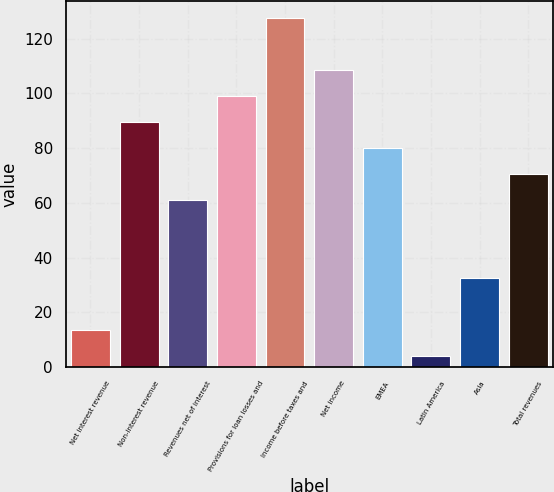<chart> <loc_0><loc_0><loc_500><loc_500><bar_chart><fcel>Net interest revenue<fcel>Non-interest revenue<fcel>Revenues net of interest<fcel>Provisions for loan losses and<fcel>Income before taxes and<fcel>Net income<fcel>EMEA<fcel>Latin America<fcel>Asia<fcel>Total revenues<nl><fcel>13.5<fcel>89.5<fcel>61<fcel>99<fcel>127.5<fcel>108.5<fcel>80<fcel>4<fcel>32.5<fcel>70.5<nl></chart> 